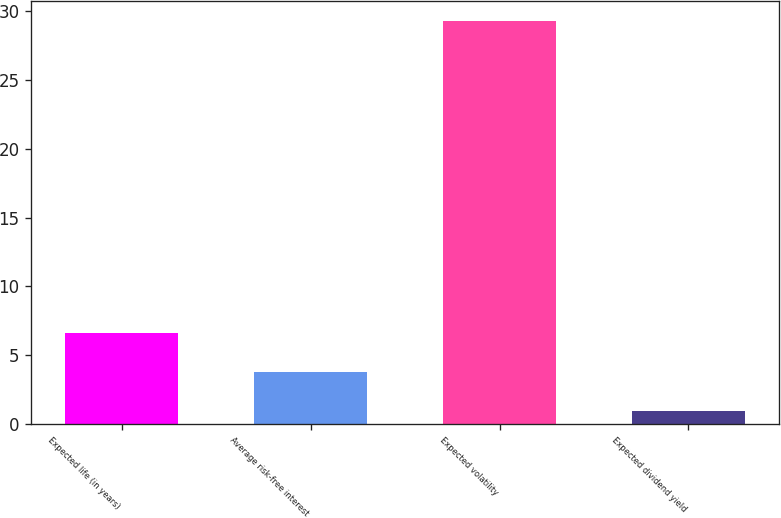Convert chart to OTSL. <chart><loc_0><loc_0><loc_500><loc_500><bar_chart><fcel>Expected life (in years)<fcel>Average risk-free interest<fcel>Expected volatility<fcel>Expected dividend yield<nl><fcel>6.6<fcel>3.76<fcel>29.3<fcel>0.92<nl></chart> 